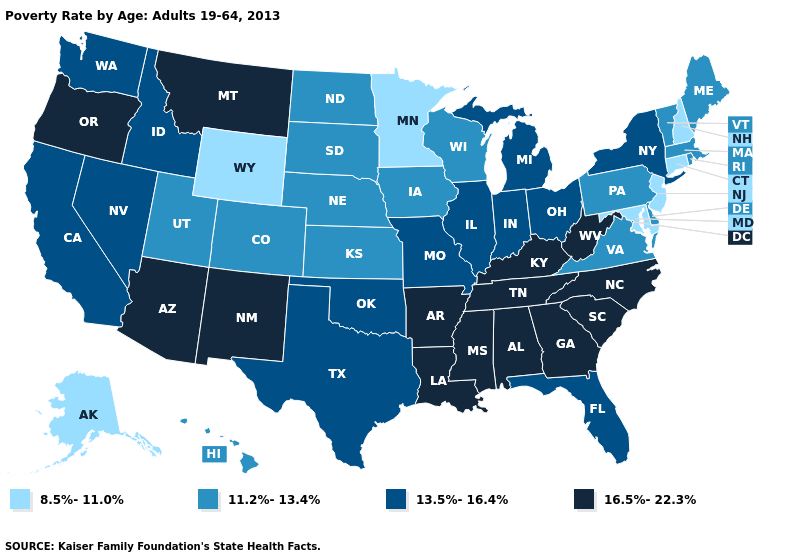Does West Virginia have the lowest value in the USA?
Give a very brief answer. No. What is the lowest value in the USA?
Keep it brief. 8.5%-11.0%. Name the states that have a value in the range 8.5%-11.0%?
Answer briefly. Alaska, Connecticut, Maryland, Minnesota, New Hampshire, New Jersey, Wyoming. Among the states that border Kansas , does Nebraska have the lowest value?
Quick response, please. Yes. Name the states that have a value in the range 13.5%-16.4%?
Concise answer only. California, Florida, Idaho, Illinois, Indiana, Michigan, Missouri, Nevada, New York, Ohio, Oklahoma, Texas, Washington. Name the states that have a value in the range 11.2%-13.4%?
Answer briefly. Colorado, Delaware, Hawaii, Iowa, Kansas, Maine, Massachusetts, Nebraska, North Dakota, Pennsylvania, Rhode Island, South Dakota, Utah, Vermont, Virginia, Wisconsin. What is the highest value in states that border Utah?
Keep it brief. 16.5%-22.3%. Among the states that border Missouri , which have the highest value?
Keep it brief. Arkansas, Kentucky, Tennessee. Name the states that have a value in the range 16.5%-22.3%?
Be succinct. Alabama, Arizona, Arkansas, Georgia, Kentucky, Louisiana, Mississippi, Montana, New Mexico, North Carolina, Oregon, South Carolina, Tennessee, West Virginia. Which states have the highest value in the USA?
Give a very brief answer. Alabama, Arizona, Arkansas, Georgia, Kentucky, Louisiana, Mississippi, Montana, New Mexico, North Carolina, Oregon, South Carolina, Tennessee, West Virginia. Does Maryland have the highest value in the South?
Be succinct. No. Does the first symbol in the legend represent the smallest category?
Quick response, please. Yes. Name the states that have a value in the range 16.5%-22.3%?
Write a very short answer. Alabama, Arizona, Arkansas, Georgia, Kentucky, Louisiana, Mississippi, Montana, New Mexico, North Carolina, Oregon, South Carolina, Tennessee, West Virginia. What is the value of Colorado?
Give a very brief answer. 11.2%-13.4%. What is the value of Montana?
Keep it brief. 16.5%-22.3%. 